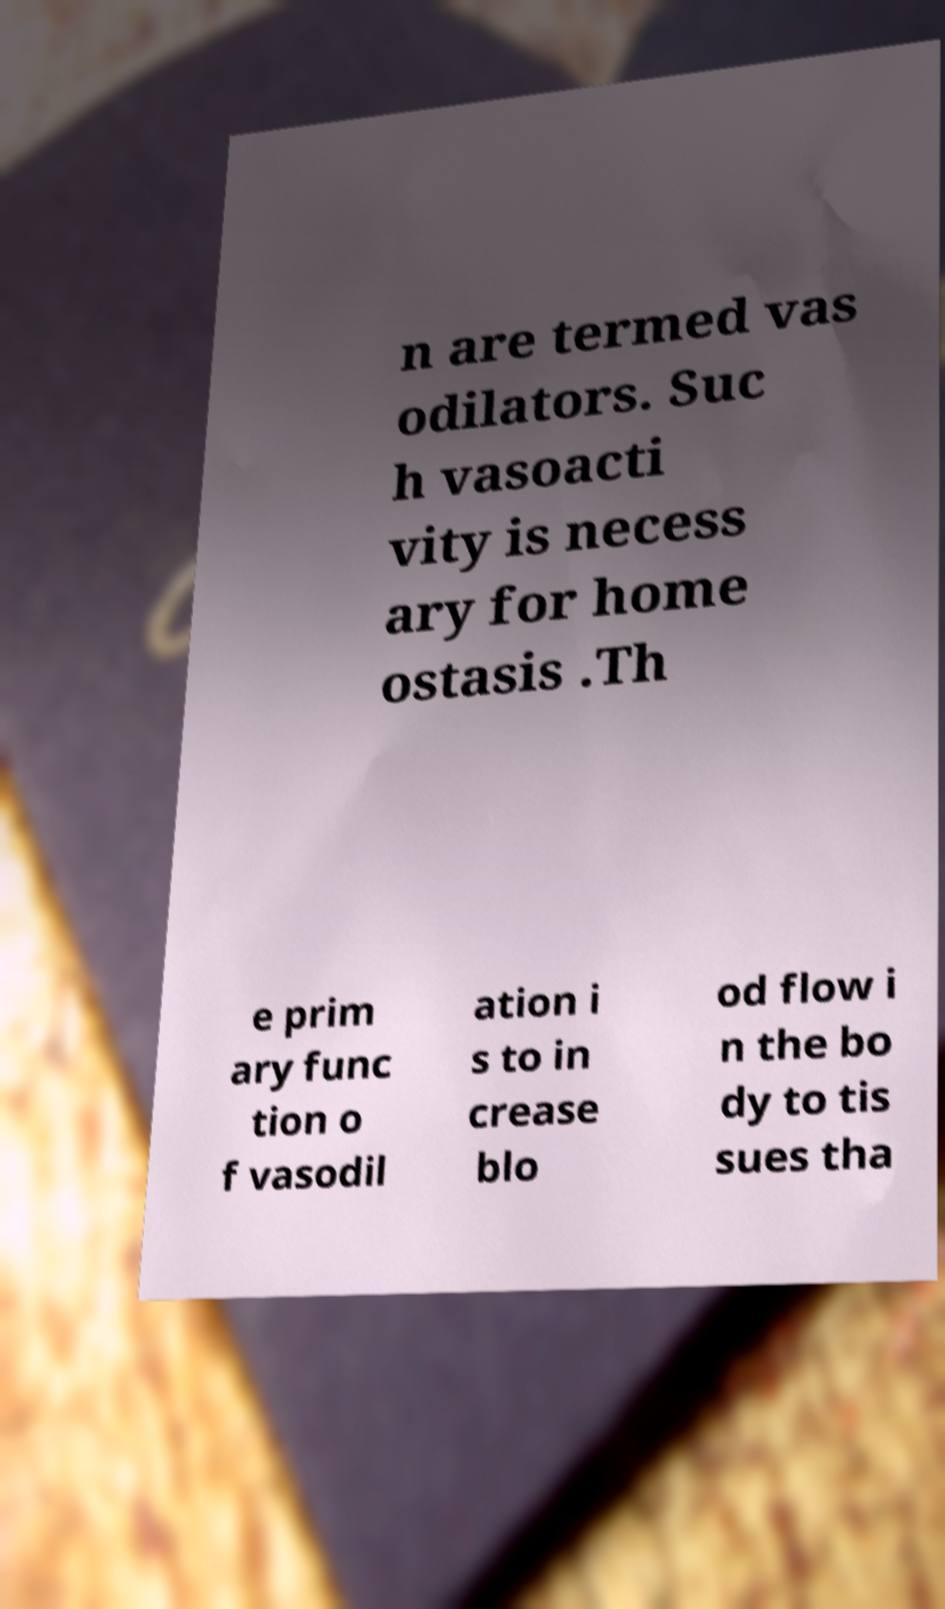Please read and relay the text visible in this image. What does it say? n are termed vas odilators. Suc h vasoacti vity is necess ary for home ostasis .Th e prim ary func tion o f vasodil ation i s to in crease blo od flow i n the bo dy to tis sues tha 